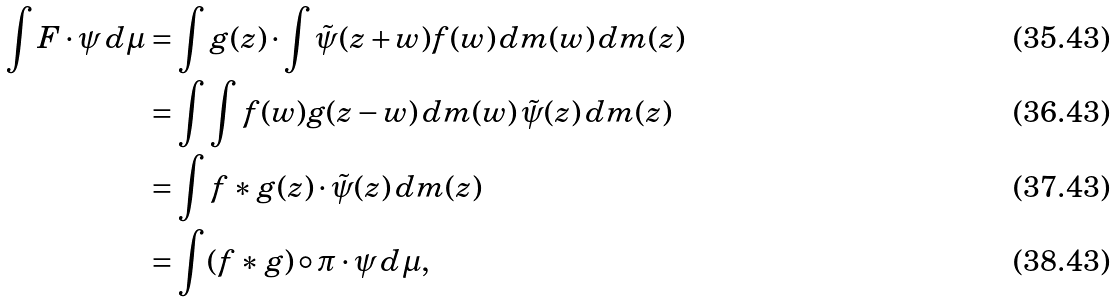Convert formula to latex. <formula><loc_0><loc_0><loc_500><loc_500>\int F \cdot \psi \, d \mu & = \int g ( z ) \cdot \int \tilde { \psi } ( z + w ) f ( w ) \, d m ( w ) \, d m ( z ) \\ & = \int \int f ( w ) g ( z - w ) \, d m ( w ) \, \tilde { \psi } ( z ) \, d m ( z ) \\ & = \int f * g ( z ) \cdot \tilde { \psi } ( z ) \, d m ( z ) \\ & = \int ( f * g ) \circ \pi \cdot \psi \, d \mu ,</formula> 